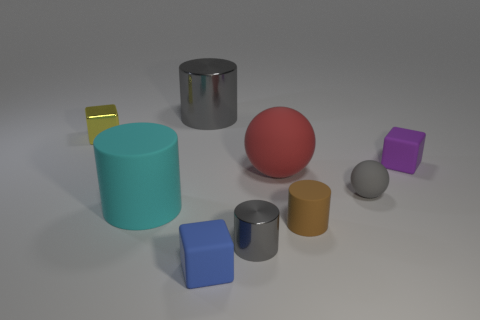What size is the other rubber thing that is the same shape as the small purple object?
Offer a terse response. Small. What number of tiny objects have the same material as the big cyan thing?
Give a very brief answer. 4. How many matte cubes are to the left of the gray cylinder that is on the right side of the blue matte thing?
Your answer should be compact. 1. There is a small rubber thing behind the big red rubber thing; is it the same shape as the tiny blue matte thing?
Keep it short and to the point. Yes. What material is the sphere that is the same color as the big shiny cylinder?
Offer a terse response. Rubber. What number of tiny cylinders have the same color as the large metal cylinder?
Keep it short and to the point. 1. There is a large rubber thing left of the gray shiny object behind the small metal block; what shape is it?
Offer a terse response. Cylinder. Is there a small metallic object that has the same shape as the small brown matte thing?
Provide a succinct answer. Yes. There is a small ball; does it have the same color as the cylinder behind the large cyan thing?
Ensure brevity in your answer.  Yes. The other metallic thing that is the same color as the large shiny thing is what size?
Keep it short and to the point. Small. 